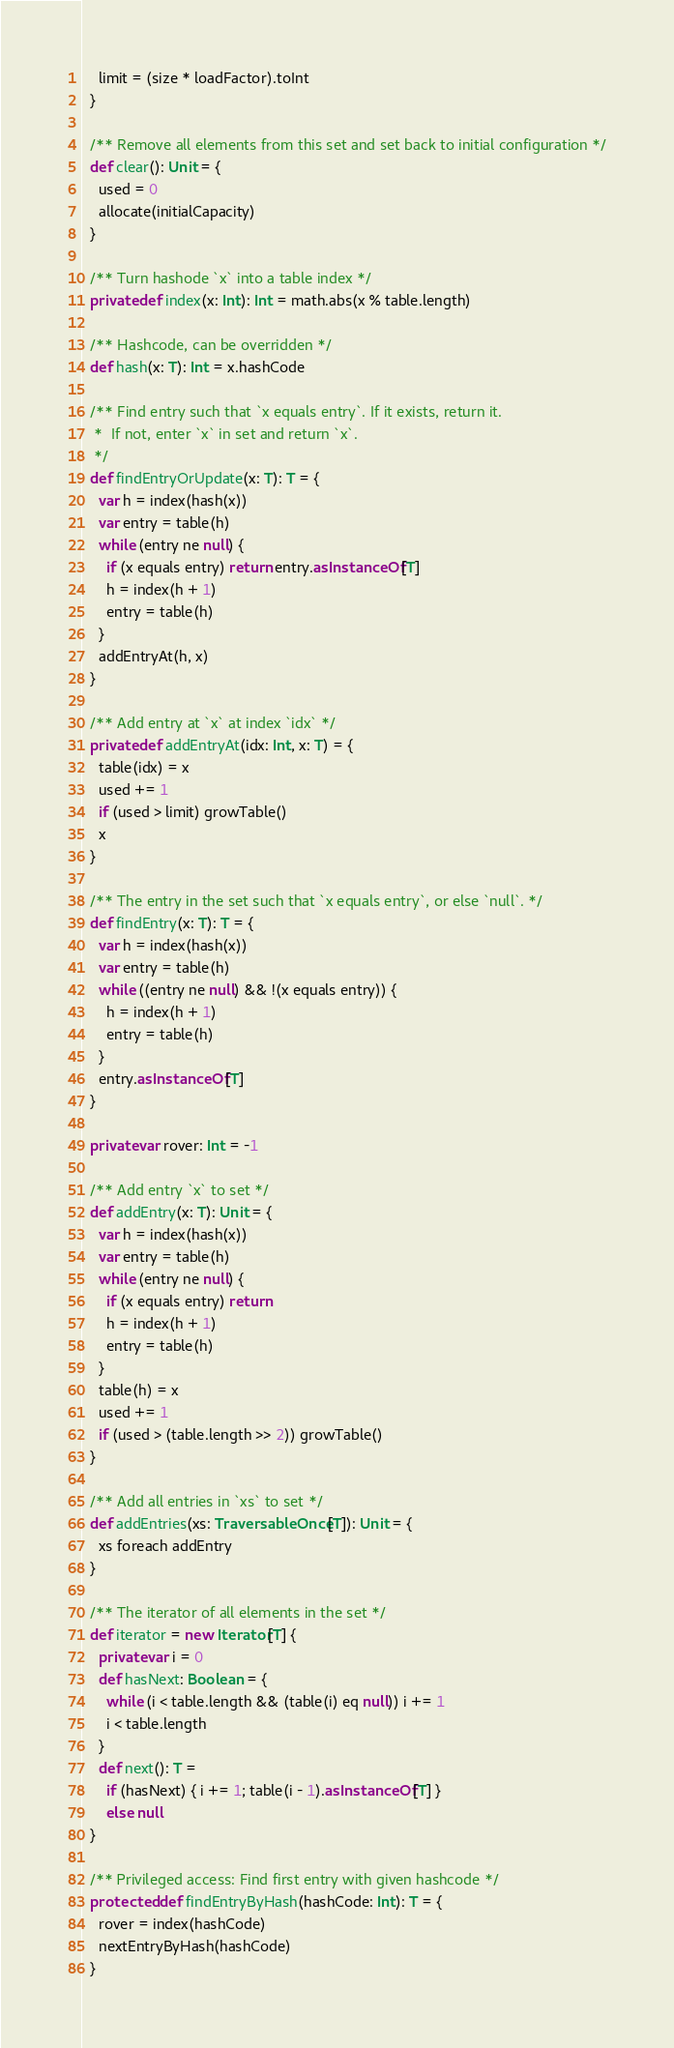Convert code to text. <code><loc_0><loc_0><loc_500><loc_500><_Scala_>    limit = (size * loadFactor).toInt
  }

  /** Remove all elements from this set and set back to initial configuration */
  def clear(): Unit = {
    used = 0
    allocate(initialCapacity)
  }

  /** Turn hashode `x` into a table index */
  private def index(x: Int): Int = math.abs(x % table.length)

  /** Hashcode, can be overridden */
  def hash(x: T): Int = x.hashCode

  /** Find entry such that `x equals entry`. If it exists, return it.
   *  If not, enter `x` in set and return `x`.
   */
  def findEntryOrUpdate(x: T): T = {
    var h = index(hash(x))
    var entry = table(h)
    while (entry ne null) {
      if (x equals entry) return entry.asInstanceOf[T]
      h = index(h + 1)
      entry = table(h)
    }
    addEntryAt(h, x)
  }

  /** Add entry at `x` at index `idx` */
  private def addEntryAt(idx: Int, x: T) = {
    table(idx) = x
    used += 1
    if (used > limit) growTable()
    x
  }

  /** The entry in the set such that `x equals entry`, or else `null`. */
  def findEntry(x: T): T = {
    var h = index(hash(x))
    var entry = table(h)
    while ((entry ne null) && !(x equals entry)) {
      h = index(h + 1)
      entry = table(h)
    }
    entry.asInstanceOf[T]
  }

  private var rover: Int = -1

  /** Add entry `x` to set */
  def addEntry(x: T): Unit = {
    var h = index(hash(x))
    var entry = table(h)
    while (entry ne null) {
      if (x equals entry) return
      h = index(h + 1)
      entry = table(h)
    }
    table(h) = x
    used += 1
    if (used > (table.length >> 2)) growTable()
  }

  /** Add all entries in `xs` to set */
  def addEntries(xs: TraversableOnce[T]): Unit = {
    xs foreach addEntry
  }

  /** The iterator of all elements in the set */
  def iterator = new Iterator[T] {
    private var i = 0
    def hasNext: Boolean = {
      while (i < table.length && (table(i) eq null)) i += 1
      i < table.length
    }
    def next(): T =
      if (hasNext) { i += 1; table(i - 1).asInstanceOf[T] }
      else null
  }

  /** Privileged access: Find first entry with given hashcode */
  protected def findEntryByHash(hashCode: Int): T = {
    rover = index(hashCode)
    nextEntryByHash(hashCode)
  }
</code> 